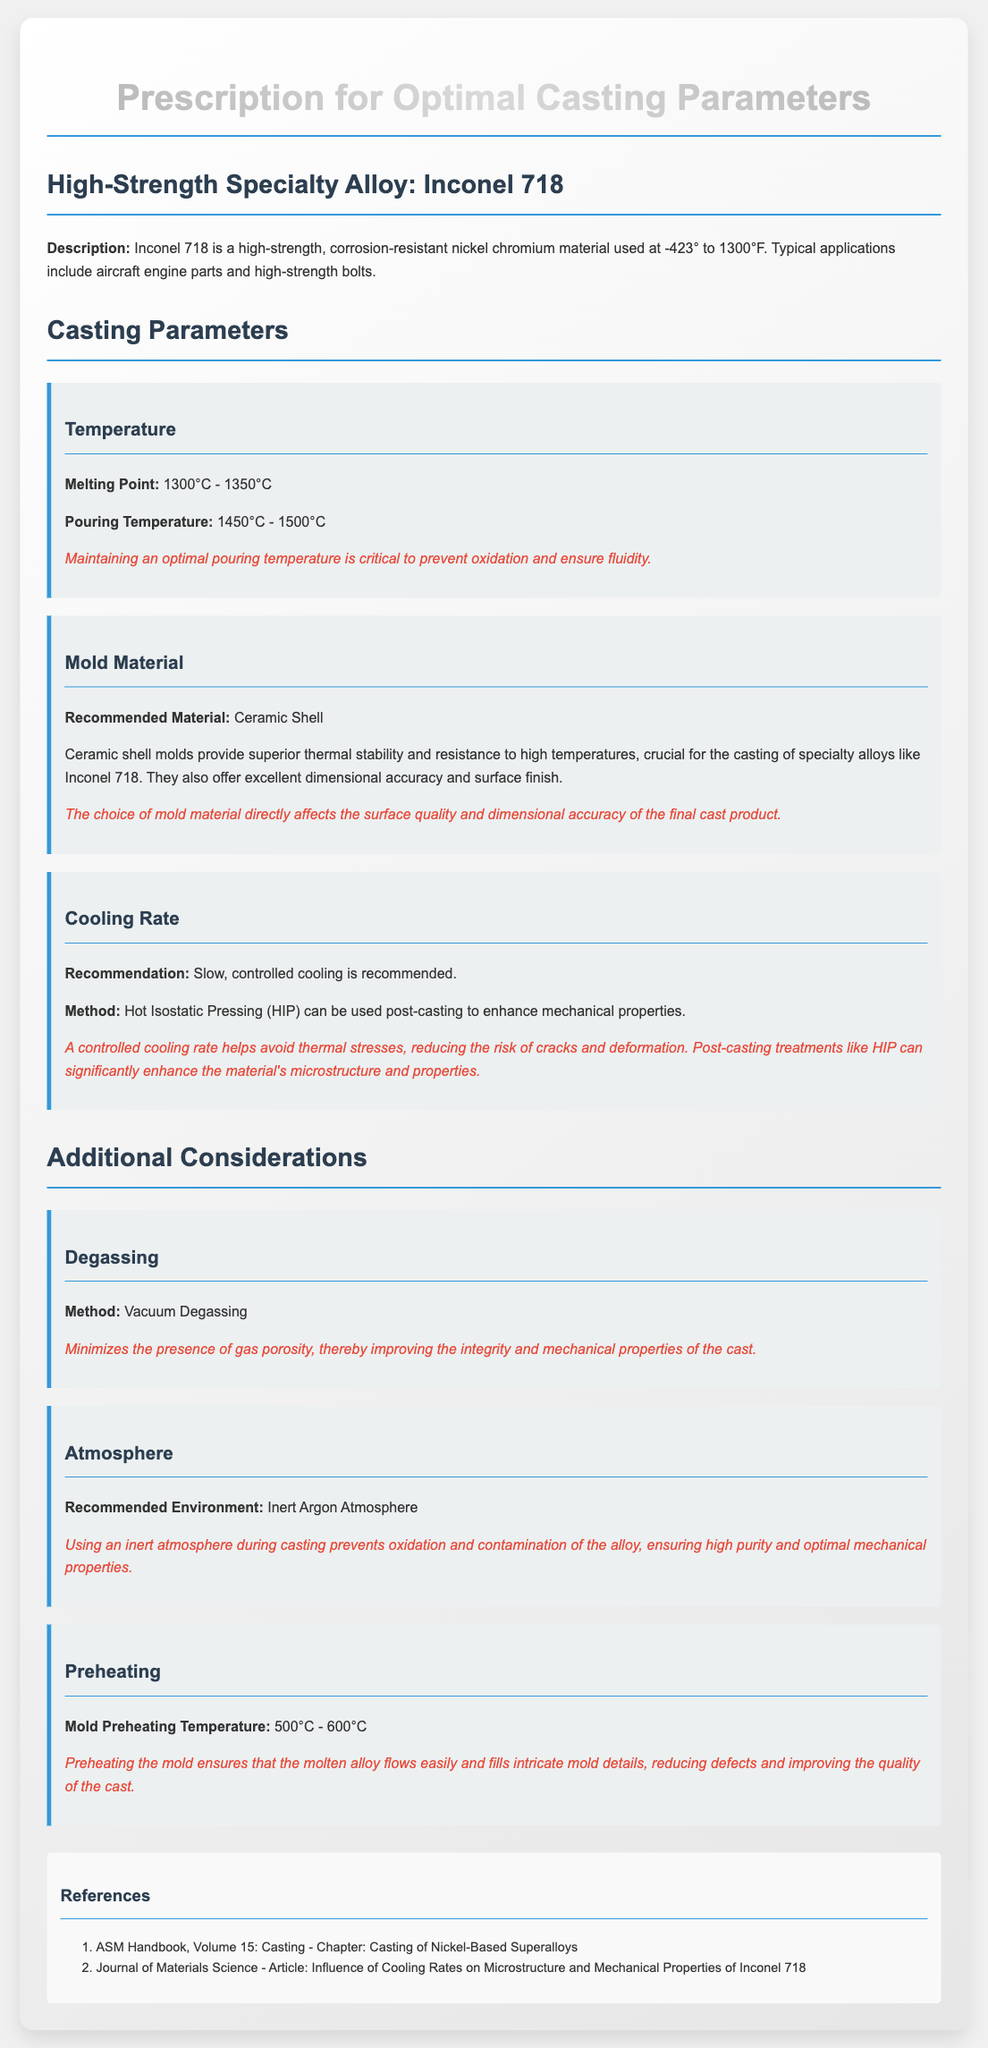what is the melting point range for Inconel 718? The melting point range is provided in the casting parameters section of the document.
Answer: 1300°C - 1350°C what is the pouring temperature range specified? This information can be found under the temperature parameter and is critical for casting.
Answer: 1450°C - 1500°C what is the recommended mold material for Inconel 718? This detail is clearly indicated in the mold material section of the document.
Answer: Ceramic Shell why is slow, controlled cooling recommended? This question requires understanding the explanation given about cooling rates and their importance.
Answer: Avoid thermal stresses what is the preheating temperature for the mold? This information can be found in the preheating section of the document.
Answer: 500°C - 600°C what method is suggested for degassing? The method for eliminating gas porosity is mentioned in the additional considerations section.
Answer: Vacuum Degassing why is an inert argon atmosphere recommended during casting? This question pertains to the preventative measures discussed in the document regarding oxidation.
Answer: Prevents oxidation and contamination what post-casting method can enhance the mechanical properties? The document specifies a method used after casting to improve properties, which requires understanding of the cooling rate section.
Answer: Hot Isostatic Pressing (HIP) 